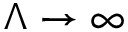Convert formula to latex. <formula><loc_0><loc_0><loc_500><loc_500>\Lambda \to \infty</formula> 